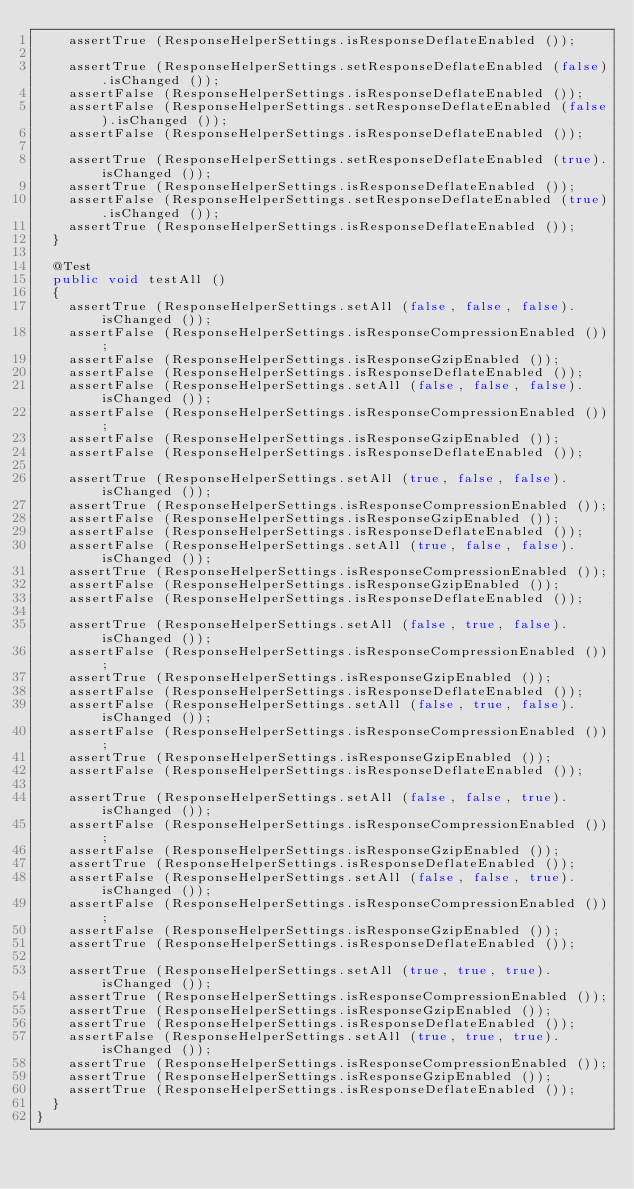Convert code to text. <code><loc_0><loc_0><loc_500><loc_500><_Java_>    assertTrue (ResponseHelperSettings.isResponseDeflateEnabled ());

    assertTrue (ResponseHelperSettings.setResponseDeflateEnabled (false).isChanged ());
    assertFalse (ResponseHelperSettings.isResponseDeflateEnabled ());
    assertFalse (ResponseHelperSettings.setResponseDeflateEnabled (false).isChanged ());
    assertFalse (ResponseHelperSettings.isResponseDeflateEnabled ());

    assertTrue (ResponseHelperSettings.setResponseDeflateEnabled (true).isChanged ());
    assertTrue (ResponseHelperSettings.isResponseDeflateEnabled ());
    assertFalse (ResponseHelperSettings.setResponseDeflateEnabled (true).isChanged ());
    assertTrue (ResponseHelperSettings.isResponseDeflateEnabled ());
  }

  @Test
  public void testAll ()
  {
    assertTrue (ResponseHelperSettings.setAll (false, false, false).isChanged ());
    assertFalse (ResponseHelperSettings.isResponseCompressionEnabled ());
    assertFalse (ResponseHelperSettings.isResponseGzipEnabled ());
    assertFalse (ResponseHelperSettings.isResponseDeflateEnabled ());
    assertFalse (ResponseHelperSettings.setAll (false, false, false).isChanged ());
    assertFalse (ResponseHelperSettings.isResponseCompressionEnabled ());
    assertFalse (ResponseHelperSettings.isResponseGzipEnabled ());
    assertFalse (ResponseHelperSettings.isResponseDeflateEnabled ());

    assertTrue (ResponseHelperSettings.setAll (true, false, false).isChanged ());
    assertTrue (ResponseHelperSettings.isResponseCompressionEnabled ());
    assertFalse (ResponseHelperSettings.isResponseGzipEnabled ());
    assertFalse (ResponseHelperSettings.isResponseDeflateEnabled ());
    assertFalse (ResponseHelperSettings.setAll (true, false, false).isChanged ());
    assertTrue (ResponseHelperSettings.isResponseCompressionEnabled ());
    assertFalse (ResponseHelperSettings.isResponseGzipEnabled ());
    assertFalse (ResponseHelperSettings.isResponseDeflateEnabled ());

    assertTrue (ResponseHelperSettings.setAll (false, true, false).isChanged ());
    assertFalse (ResponseHelperSettings.isResponseCompressionEnabled ());
    assertTrue (ResponseHelperSettings.isResponseGzipEnabled ());
    assertFalse (ResponseHelperSettings.isResponseDeflateEnabled ());
    assertFalse (ResponseHelperSettings.setAll (false, true, false).isChanged ());
    assertFalse (ResponseHelperSettings.isResponseCompressionEnabled ());
    assertTrue (ResponseHelperSettings.isResponseGzipEnabled ());
    assertFalse (ResponseHelperSettings.isResponseDeflateEnabled ());

    assertTrue (ResponseHelperSettings.setAll (false, false, true).isChanged ());
    assertFalse (ResponseHelperSettings.isResponseCompressionEnabled ());
    assertFalse (ResponseHelperSettings.isResponseGzipEnabled ());
    assertTrue (ResponseHelperSettings.isResponseDeflateEnabled ());
    assertFalse (ResponseHelperSettings.setAll (false, false, true).isChanged ());
    assertFalse (ResponseHelperSettings.isResponseCompressionEnabled ());
    assertFalse (ResponseHelperSettings.isResponseGzipEnabled ());
    assertTrue (ResponseHelperSettings.isResponseDeflateEnabled ());

    assertTrue (ResponseHelperSettings.setAll (true, true, true).isChanged ());
    assertTrue (ResponseHelperSettings.isResponseCompressionEnabled ());
    assertTrue (ResponseHelperSettings.isResponseGzipEnabled ());
    assertTrue (ResponseHelperSettings.isResponseDeflateEnabled ());
    assertFalse (ResponseHelperSettings.setAll (true, true, true).isChanged ());
    assertTrue (ResponseHelperSettings.isResponseCompressionEnabled ());
    assertTrue (ResponseHelperSettings.isResponseGzipEnabled ());
    assertTrue (ResponseHelperSettings.isResponseDeflateEnabled ());
  }
}
</code> 